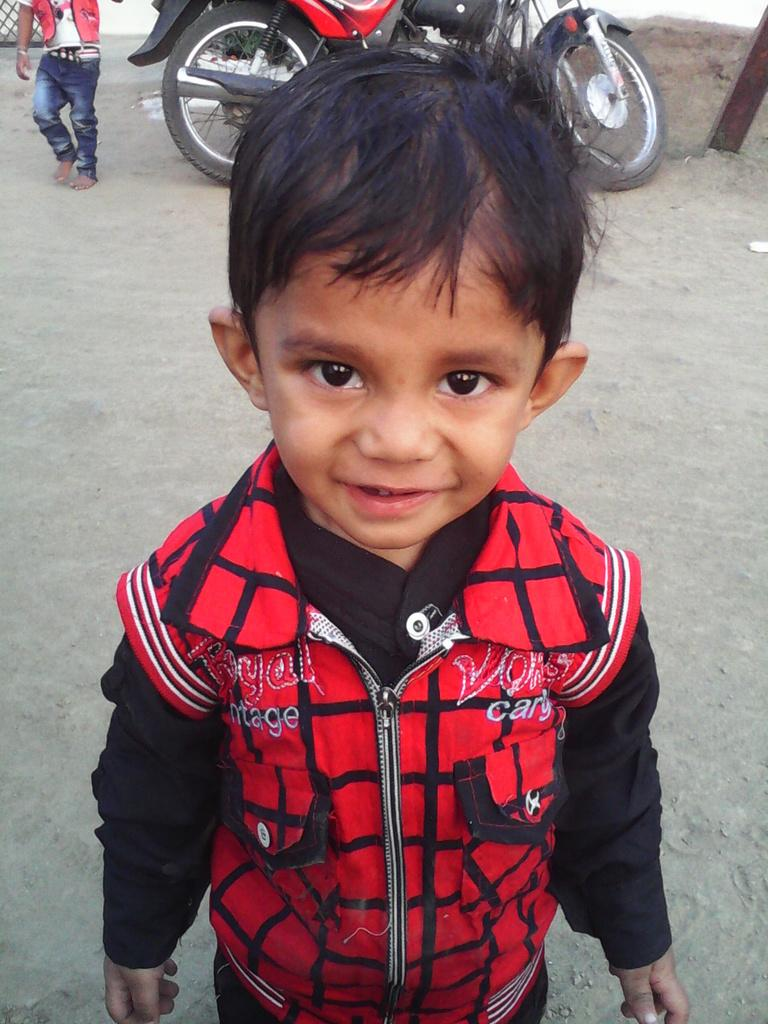What is the main subject of the image? There is a child in the image. What else can be seen in the image besides the child? There is a motor vehicle and a person beside the motor vehicle in the image. What type of committee is meeting in the image? There is no committee meeting in the image; it only features a child, a motor vehicle, and a person beside the motor vehicle. 